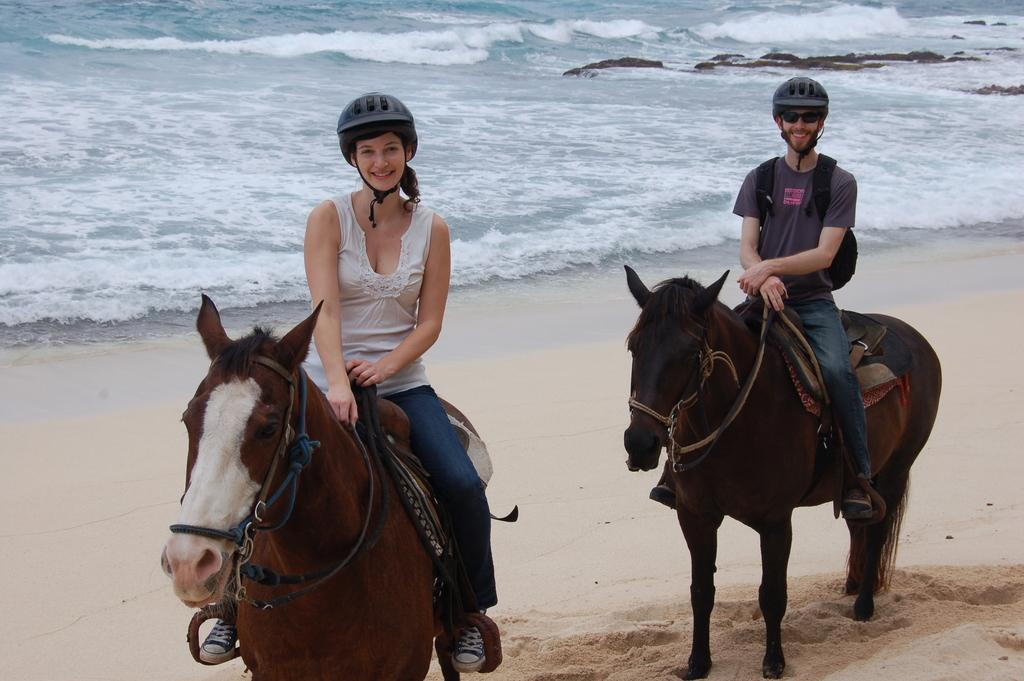Who can be seen in the image? There is a woman and a man in the image. What are the woman and the man doing in the image? Both the woman and the man are sitting on horses. What can be seen in the background of the image? There is water, rocks, and sand visible in the background of the image. How many apples are being held by the woman in the image? There are no apples present in the image; the woman and the man are sitting on horses. 